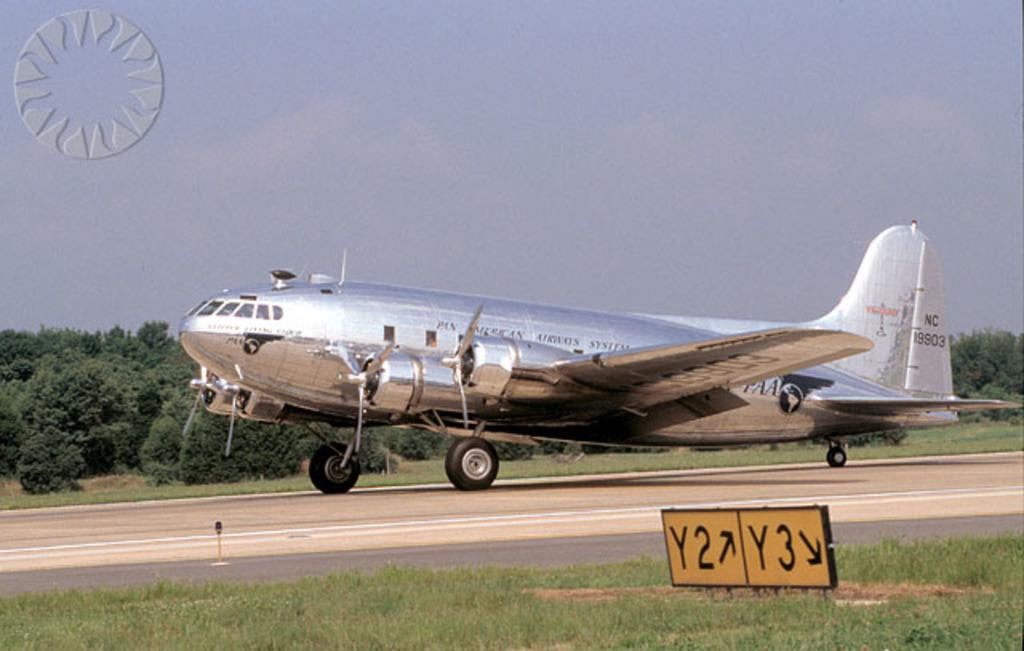<image>
Present a compact description of the photo's key features. A plane taxing on the runway in fron ot which is a direction sign: "Y2 / Y3" 